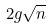Convert formula to latex. <formula><loc_0><loc_0><loc_500><loc_500>2 g \sqrt { n }</formula> 